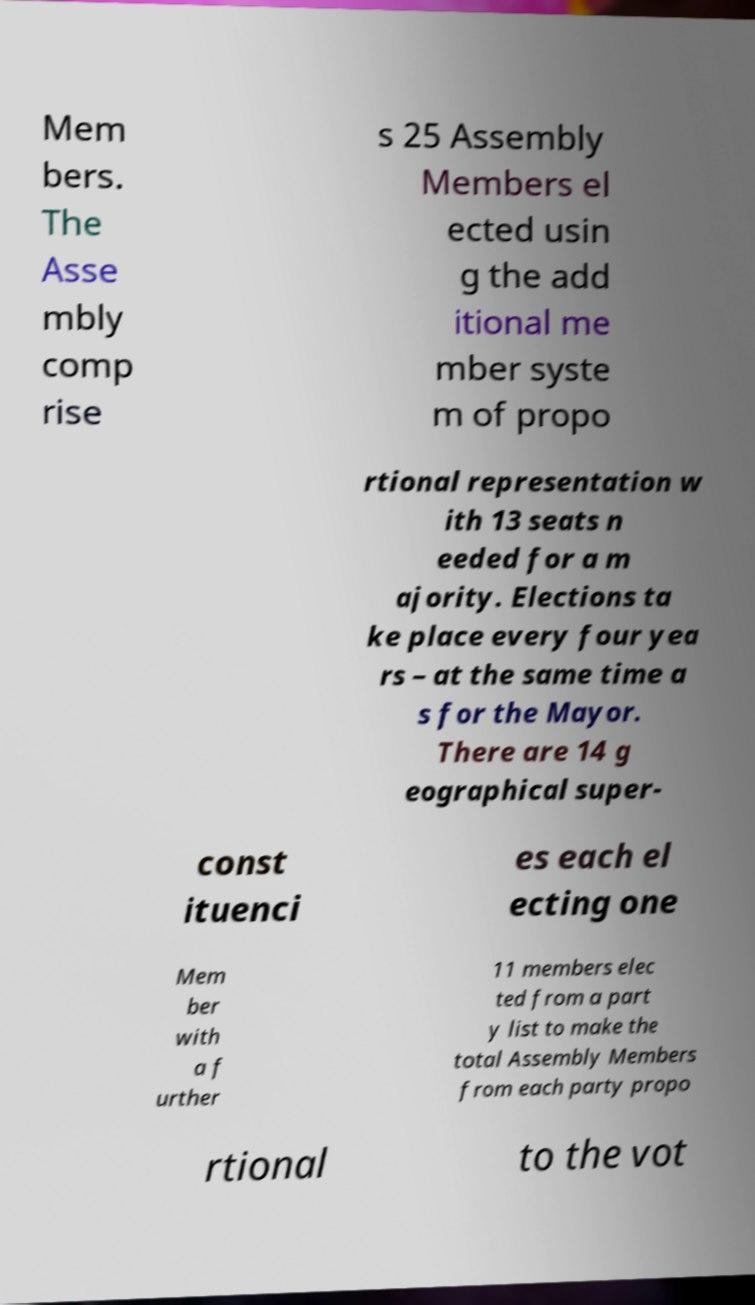For documentation purposes, I need the text within this image transcribed. Could you provide that? Mem bers. The Asse mbly comp rise s 25 Assembly Members el ected usin g the add itional me mber syste m of propo rtional representation w ith 13 seats n eeded for a m ajority. Elections ta ke place every four yea rs – at the same time a s for the Mayor. There are 14 g eographical super- const ituenci es each el ecting one Mem ber with a f urther 11 members elec ted from a part y list to make the total Assembly Members from each party propo rtional to the vot 